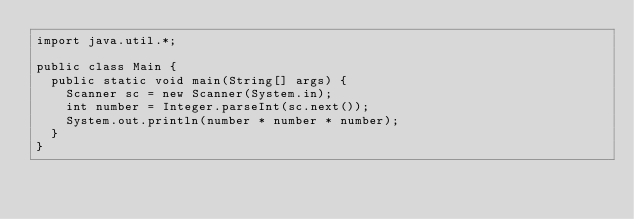Convert code to text. <code><loc_0><loc_0><loc_500><loc_500><_Java_>import java.util.*;

public class Main {
  public static void main(String[] args) {
    Scanner sc = new Scanner(System.in);
    int number = Integer.parseInt(sc.next());
    System.out.println(number * number * number);
  }
}
</code> 